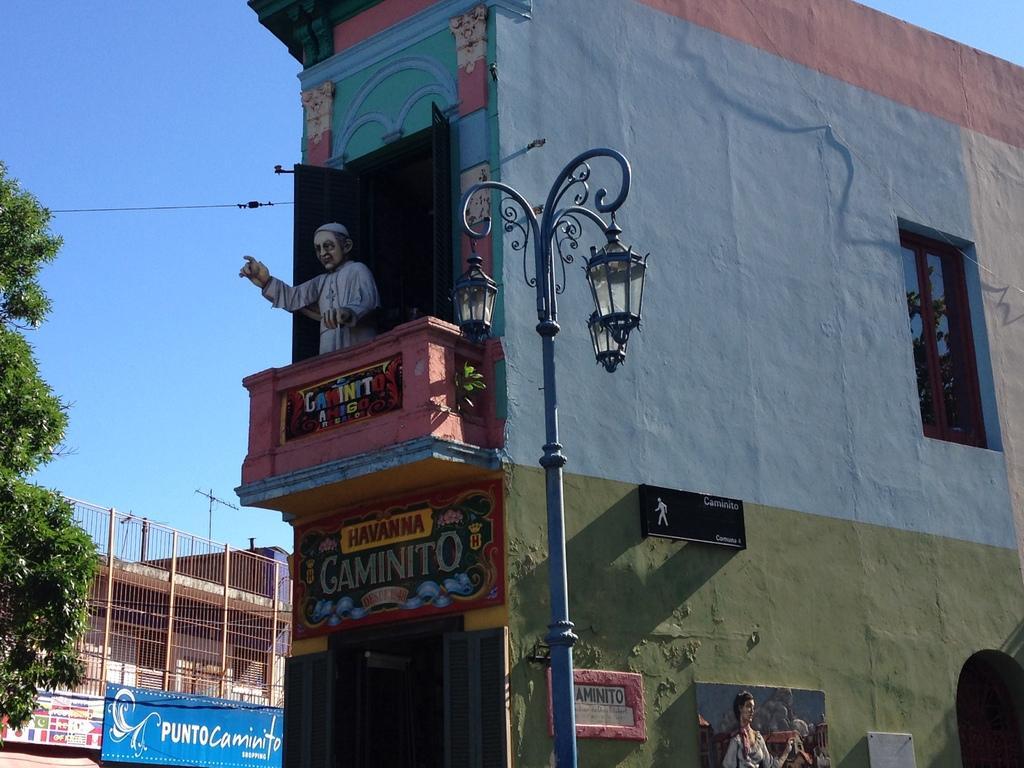Describe this image in one or two sentences. This picture might be taken from outside of the building and it is sunny. In this image, in the middle, we can see a street light. On the right side, we can see a board, hoardings and a painting. In the middle image, we can also see a sculpture, doors. On the left side, we can see a hoardings, metal grill, building. At the top, we can see electric wire and a sky. 